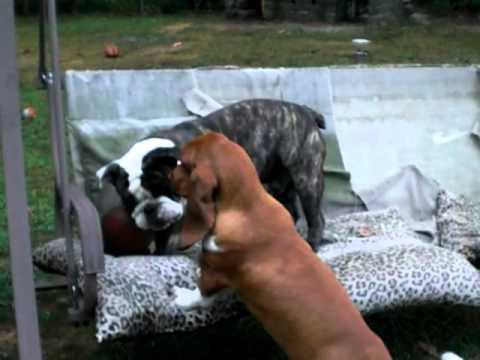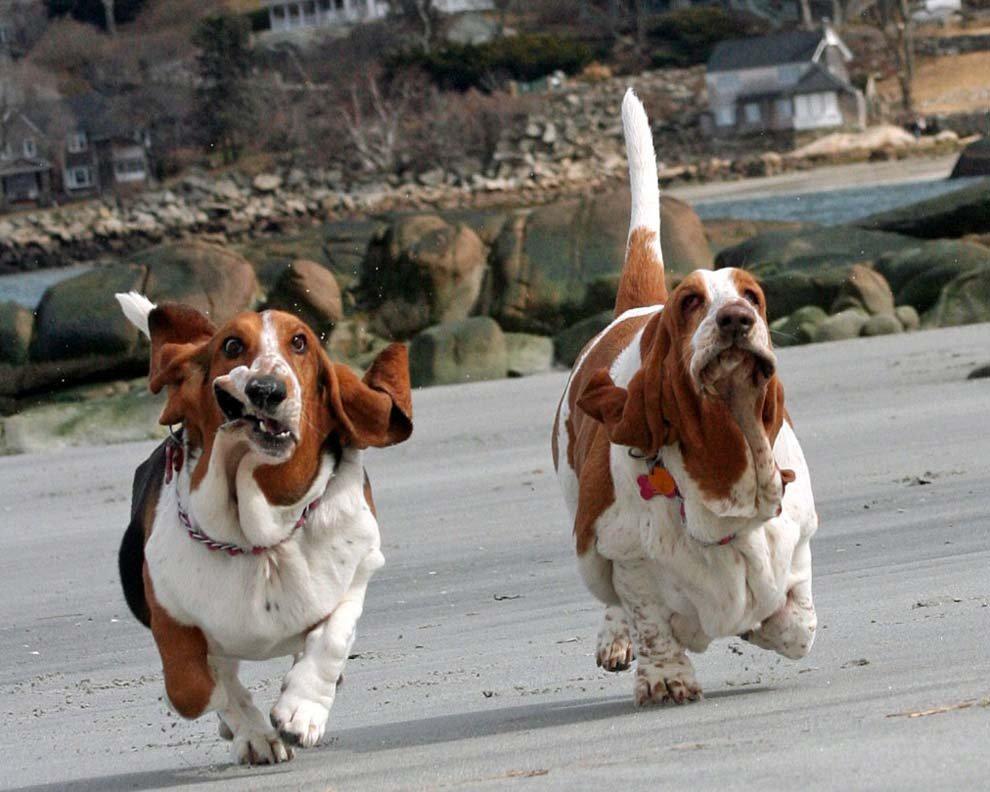The first image is the image on the left, the second image is the image on the right. Analyze the images presented: Is the assertion "One image contains two basset hounds and no humans, and the other image includes at least one person with multiple basset hounds on leashes." valid? Answer yes or no. No. The first image is the image on the left, the second image is the image on the right. Given the left and right images, does the statement "One picture has atleast 2 dogs and a person." hold true? Answer yes or no. No. 